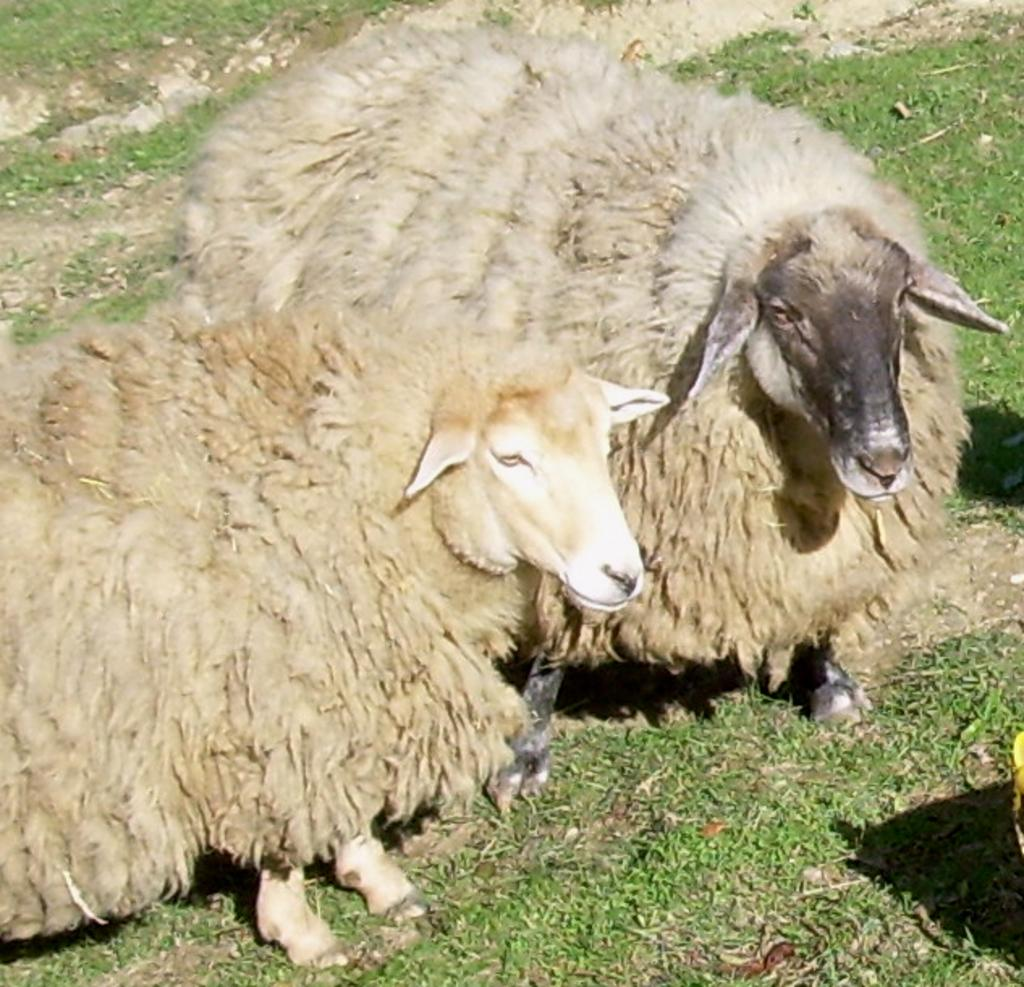What animals are present in the image? There are sheeps in the image. Where are the sheeps located? The sheeps are on the grass. What type of nut can be seen in the image? There is no nut present in the image; it features sheeps on the grass. Are the sheeps involved in a fight in the image? There is no fight depicted in the image; the sheeps are simply on the grass. 